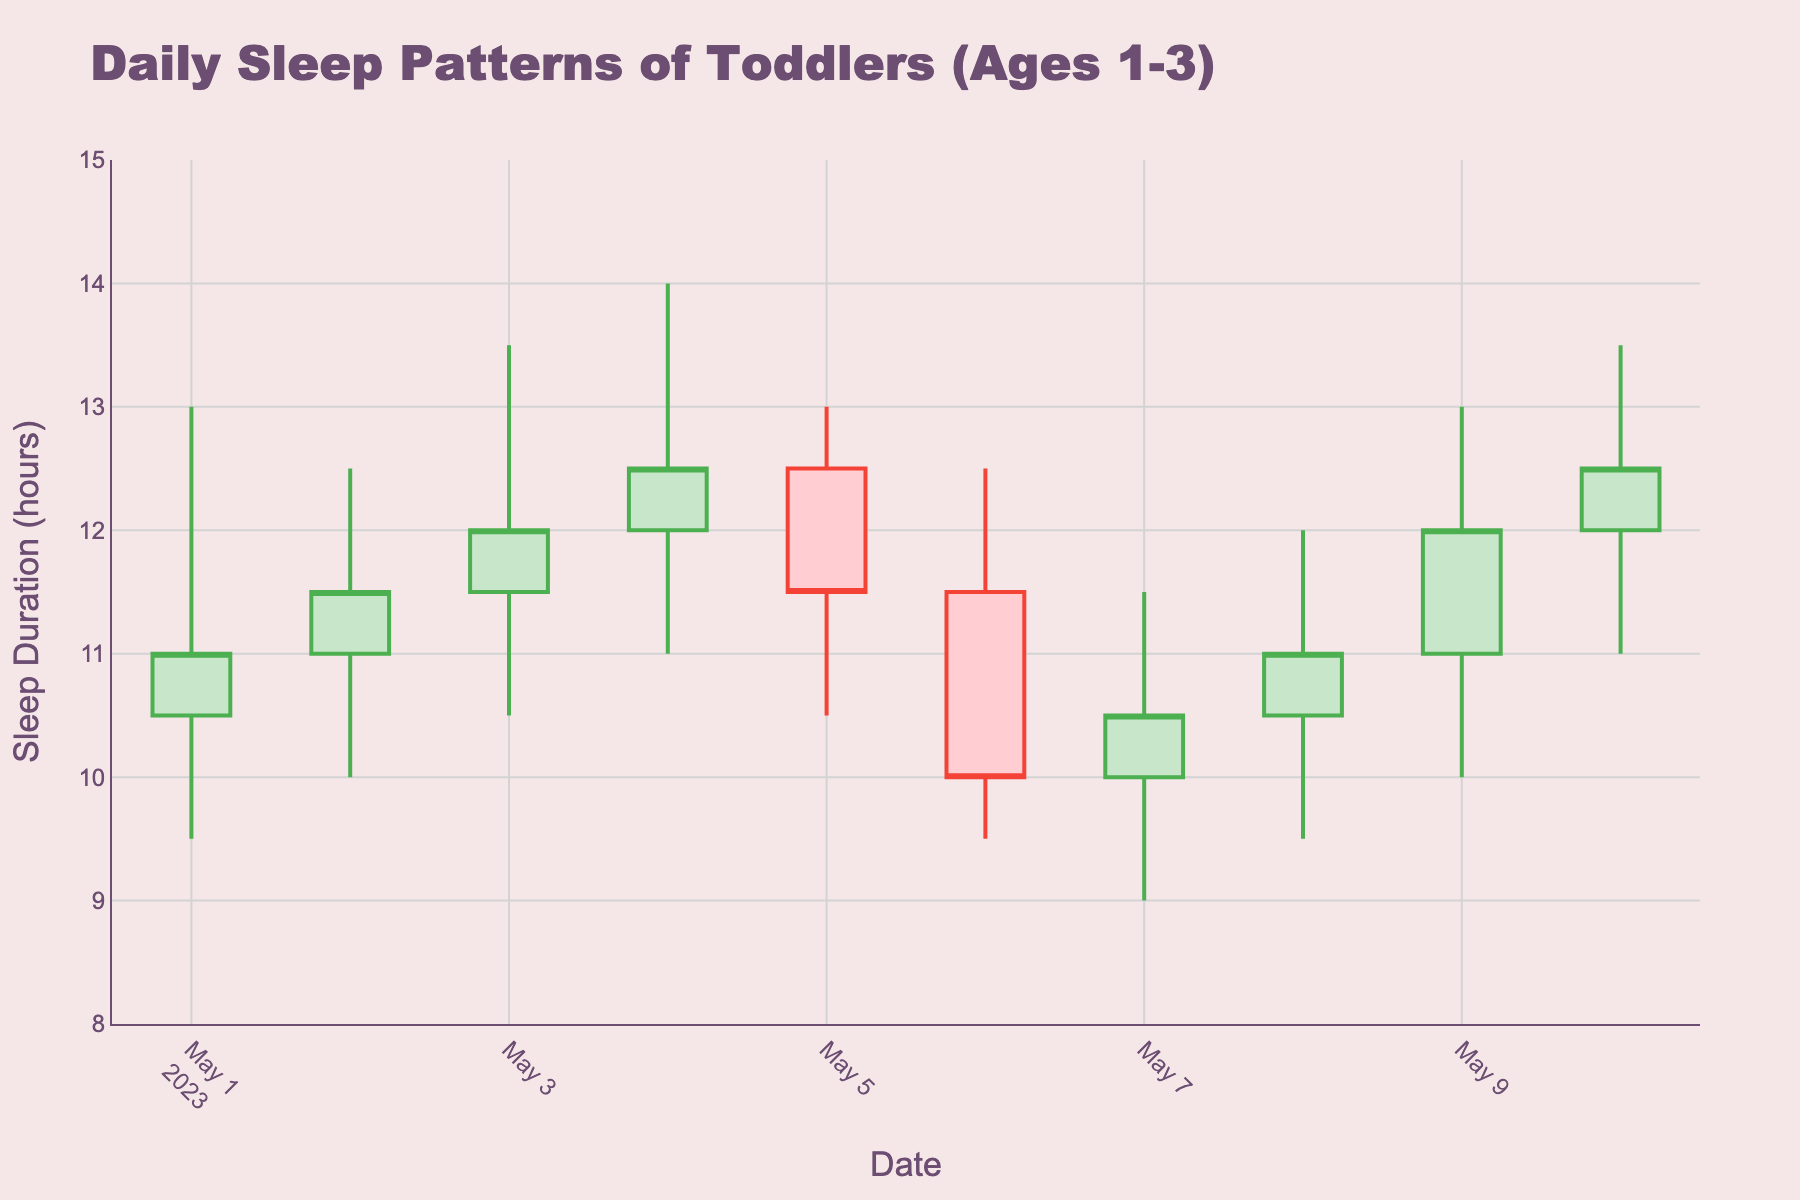What's the title of the figure? The title is displayed at the top of the figure. It is written in larger font and stands out due to its color and size. It says "Daily Sleep Patterns of Toddlers (Ages 1-3)".
Answer: Daily Sleep Patterns of Toddlers (Ages 1-3) How many data points are presented in the figure? Each day represents one data point, and the dates range from 2023-05-01 to 2023-05-10. Counting these dates gives us 10 data points.
Answer: 10 What's the range of the y-axis? The y-axis range is often displayed beside the axis itself, from the lowest to the highest tick. It shows sleep duration range from 8 to 15 hours.
Answer: 8 to 15 By how much did the sleep duration change from May 1st to May 2nd? The sleep duration on May 1st (Close) is 11 hours and on May 2nd is 11.5 hours. The difference is found by subtraction: 11.5 - 11.
Answer: 0.5 hours Which day had the highest sleep duration? The highest sleep duration for each day is given by the 'High' value in the OHLC chart. The maximum value among the given data points is 14 hours on May 4th.
Answer: May 4 On which day was the lowest sleep duration recorded, and what was it? The lowest sleep duration each day is represented by the 'Low' value in the OHLC chart. The minimum value among the given data points is 9 hours on May 7th.
Answer: May 7, 9 hours What is the average closing sleep duration over the 10 days? To find the average closing sleep duration, sum all the 'Close' values and divide by the number of data points. (11 + 11.5 + 12 + 12.5 + 11.5 + 10 + 10.5 + 11 + 12 + 12.5) / 10 = 114.5 / 10.
Answer: 11.45 hours How does the sleep pattern on May 6th compare to May 8th in terms of sleep duration changes? On May 6th, the sleep duration was between 9.5 (Low) and 12.5 hours (High), and it closed at 10 hours. On May 8th, it ranged between 9.5 (Low) and 12 hours (High), and it closed at 11 hours. Both days had similar ranges, but May 8th closed higher by 1 hour.
Answer: May 8 closed higher What’s the trend seen in the first 5 days (May 1st to May 5th) considering the closing sleep durations? The closing sleep durations are: 11, 11.5, 12, 12.5, 11.5. There’s a general upward trend for the first 4 days, from 11 to 12.5, followed by a slight drop on the 5th day.
Answer: Upward trend, slight drop on 5th day Can we observe any cycles or patterns in the sleep duration over the 10 days? Analyzing for any repeated behaviour or variation patterns, we see slight fluctuations but no distinct cyclic pattern. The sleep duration fluctuates without a clear repetitive behavior.
Answer: No distinct pattern 